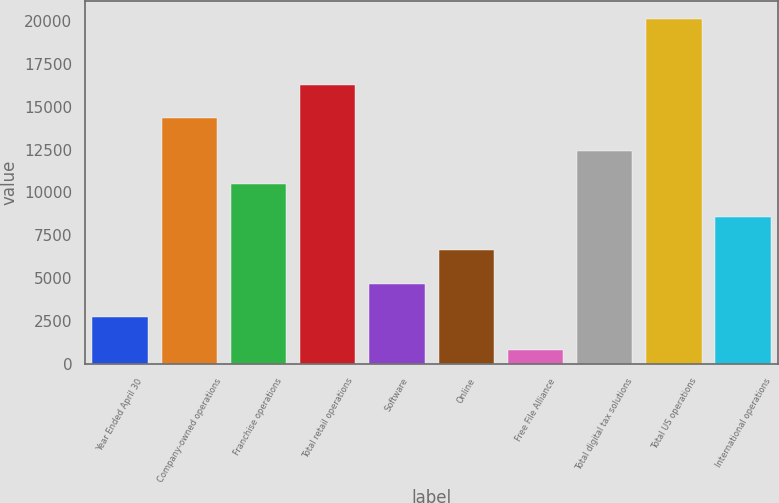<chart> <loc_0><loc_0><loc_500><loc_500><bar_chart><fcel>Year Ended April 30<fcel>Company-owned operations<fcel>Franchise operations<fcel>Total retail operations<fcel>Software<fcel>Online<fcel>Free File Alliance<fcel>Total digital tax solutions<fcel>Total US operations<fcel>International operations<nl><fcel>2743.2<fcel>14342.4<fcel>10476<fcel>16275.6<fcel>4676.4<fcel>6609.6<fcel>810<fcel>12409.2<fcel>20142<fcel>8542.8<nl></chart> 